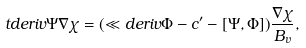Convert formula to latex. <formula><loc_0><loc_0><loc_500><loc_500>\ t d e r i v { \Psi } \nabla \chi = ( \ll d e r i v \Phi - c ^ { \prime } - [ \Psi , \Phi ] ) \frac { \nabla \chi } { B _ { v } } ,</formula> 